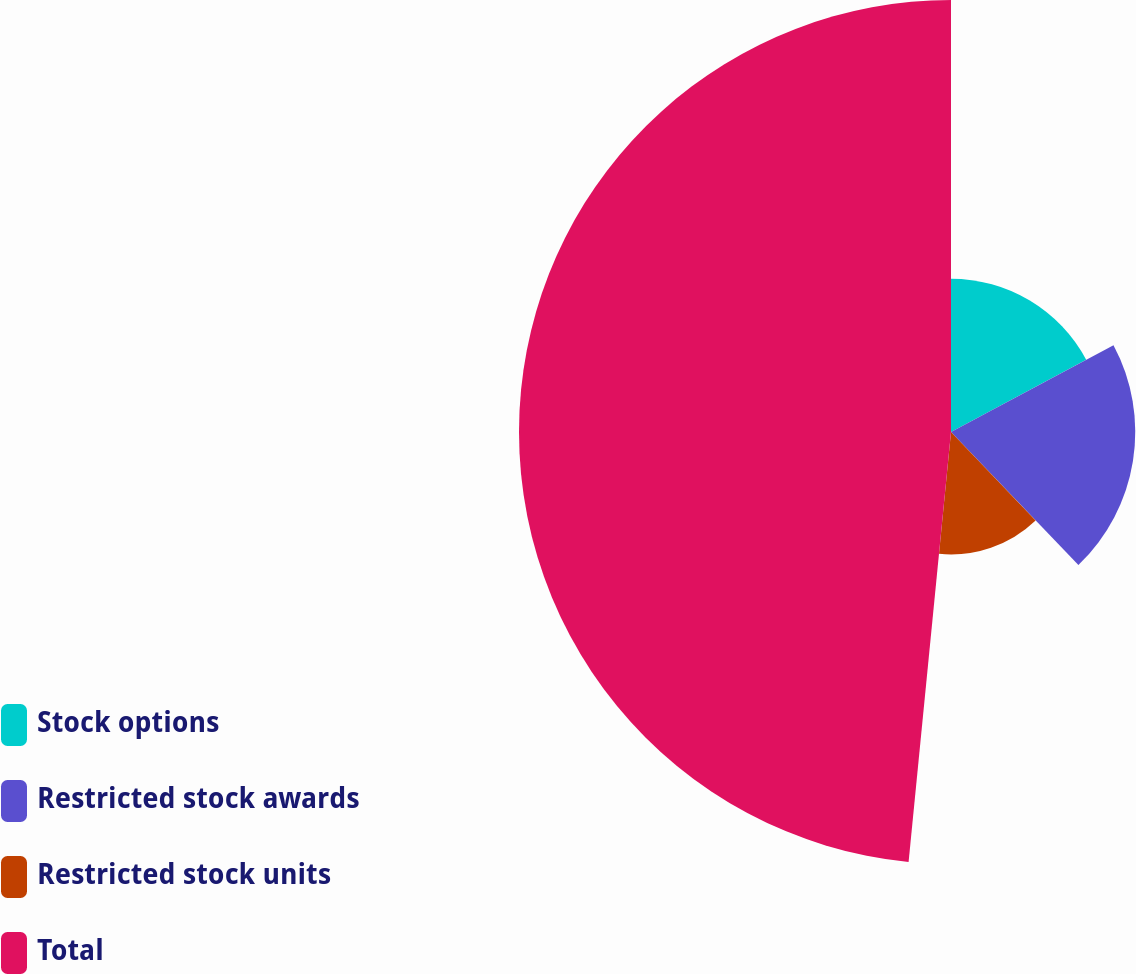<chart> <loc_0><loc_0><loc_500><loc_500><pie_chart><fcel>Stock options<fcel>Restricted stock awards<fcel>Restricted stock units<fcel>Total<nl><fcel>17.19%<fcel>20.66%<fcel>13.72%<fcel>48.44%<nl></chart> 